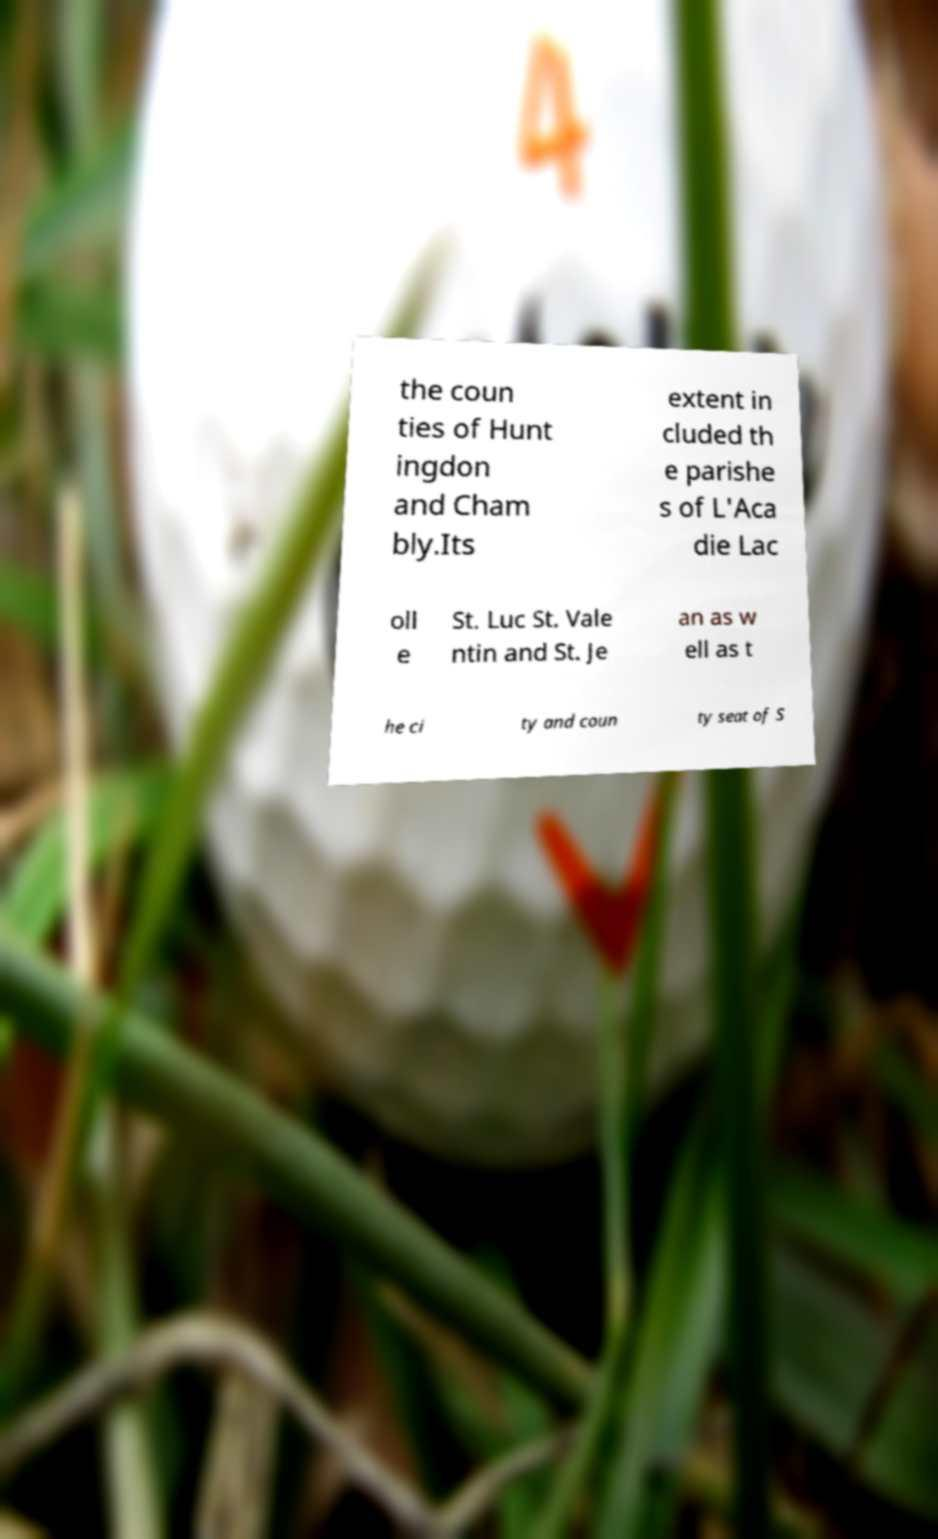Could you extract and type out the text from this image? the coun ties of Hunt ingdon and Cham bly.Its extent in cluded th e parishe s of L'Aca die Lac oll e St. Luc St. Vale ntin and St. Je an as w ell as t he ci ty and coun ty seat of S 